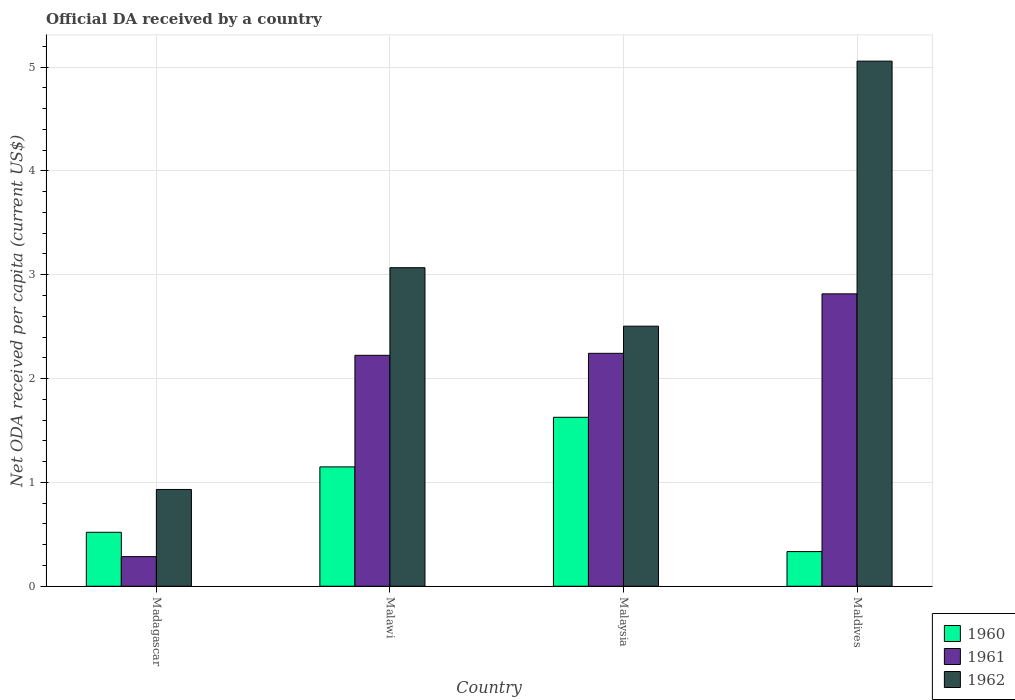How many different coloured bars are there?
Ensure brevity in your answer.  3. How many bars are there on the 2nd tick from the right?
Provide a succinct answer. 3. What is the label of the 2nd group of bars from the left?
Your answer should be very brief. Malawi. What is the ODA received in in 1960 in Madagascar?
Your response must be concise. 0.52. Across all countries, what is the maximum ODA received in in 1960?
Offer a very short reply. 1.63. Across all countries, what is the minimum ODA received in in 1960?
Offer a terse response. 0.33. In which country was the ODA received in in 1960 maximum?
Provide a short and direct response. Malaysia. In which country was the ODA received in in 1961 minimum?
Provide a succinct answer. Madagascar. What is the total ODA received in in 1962 in the graph?
Provide a short and direct response. 11.56. What is the difference between the ODA received in in 1960 in Malaysia and that in Maldives?
Offer a very short reply. 1.29. What is the difference between the ODA received in in 1962 in Malawi and the ODA received in in 1961 in Madagascar?
Give a very brief answer. 2.78. What is the average ODA received in in 1962 per country?
Keep it short and to the point. 2.89. What is the difference between the ODA received in of/in 1960 and ODA received in of/in 1961 in Malawi?
Your response must be concise. -1.07. In how many countries, is the ODA received in in 1962 greater than 2.4 US$?
Offer a very short reply. 3. What is the ratio of the ODA received in in 1961 in Malawi to that in Maldives?
Ensure brevity in your answer.  0.79. Is the ODA received in in 1960 in Madagascar less than that in Malawi?
Offer a very short reply. Yes. Is the difference between the ODA received in in 1960 in Malawi and Malaysia greater than the difference between the ODA received in in 1961 in Malawi and Malaysia?
Offer a very short reply. No. What is the difference between the highest and the second highest ODA received in in 1962?
Ensure brevity in your answer.  -0.56. What is the difference between the highest and the lowest ODA received in in 1960?
Your response must be concise. 1.29. In how many countries, is the ODA received in in 1961 greater than the average ODA received in in 1961 taken over all countries?
Give a very brief answer. 3. Is the sum of the ODA received in in 1960 in Madagascar and Malawi greater than the maximum ODA received in in 1961 across all countries?
Offer a very short reply. No. What does the 3rd bar from the right in Malaysia represents?
Offer a very short reply. 1960. How many countries are there in the graph?
Offer a terse response. 4. What is the difference between two consecutive major ticks on the Y-axis?
Ensure brevity in your answer.  1. Does the graph contain grids?
Ensure brevity in your answer.  Yes. How are the legend labels stacked?
Ensure brevity in your answer.  Vertical. What is the title of the graph?
Keep it short and to the point. Official DA received by a country. Does "1998" appear as one of the legend labels in the graph?
Offer a very short reply. No. What is the label or title of the X-axis?
Keep it short and to the point. Country. What is the label or title of the Y-axis?
Provide a succinct answer. Net ODA received per capita (current US$). What is the Net ODA received per capita (current US$) in 1960 in Madagascar?
Provide a short and direct response. 0.52. What is the Net ODA received per capita (current US$) in 1961 in Madagascar?
Offer a very short reply. 0.29. What is the Net ODA received per capita (current US$) of 1962 in Madagascar?
Offer a very short reply. 0.93. What is the Net ODA received per capita (current US$) of 1960 in Malawi?
Your answer should be very brief. 1.15. What is the Net ODA received per capita (current US$) of 1961 in Malawi?
Provide a succinct answer. 2.22. What is the Net ODA received per capita (current US$) of 1962 in Malawi?
Make the answer very short. 3.07. What is the Net ODA received per capita (current US$) in 1960 in Malaysia?
Your response must be concise. 1.63. What is the Net ODA received per capita (current US$) in 1961 in Malaysia?
Your answer should be very brief. 2.24. What is the Net ODA received per capita (current US$) in 1962 in Malaysia?
Give a very brief answer. 2.5. What is the Net ODA received per capita (current US$) of 1960 in Maldives?
Provide a succinct answer. 0.33. What is the Net ODA received per capita (current US$) of 1961 in Maldives?
Offer a terse response. 2.82. What is the Net ODA received per capita (current US$) in 1962 in Maldives?
Ensure brevity in your answer.  5.06. Across all countries, what is the maximum Net ODA received per capita (current US$) of 1960?
Offer a terse response. 1.63. Across all countries, what is the maximum Net ODA received per capita (current US$) of 1961?
Provide a succinct answer. 2.82. Across all countries, what is the maximum Net ODA received per capita (current US$) of 1962?
Give a very brief answer. 5.06. Across all countries, what is the minimum Net ODA received per capita (current US$) of 1960?
Your answer should be compact. 0.33. Across all countries, what is the minimum Net ODA received per capita (current US$) of 1961?
Give a very brief answer. 0.29. Across all countries, what is the minimum Net ODA received per capita (current US$) in 1962?
Offer a very short reply. 0.93. What is the total Net ODA received per capita (current US$) in 1960 in the graph?
Make the answer very short. 3.63. What is the total Net ODA received per capita (current US$) in 1961 in the graph?
Provide a succinct answer. 7.57. What is the total Net ODA received per capita (current US$) of 1962 in the graph?
Keep it short and to the point. 11.56. What is the difference between the Net ODA received per capita (current US$) in 1960 in Madagascar and that in Malawi?
Provide a succinct answer. -0.63. What is the difference between the Net ODA received per capita (current US$) of 1961 in Madagascar and that in Malawi?
Offer a terse response. -1.94. What is the difference between the Net ODA received per capita (current US$) of 1962 in Madagascar and that in Malawi?
Provide a succinct answer. -2.14. What is the difference between the Net ODA received per capita (current US$) of 1960 in Madagascar and that in Malaysia?
Offer a very short reply. -1.11. What is the difference between the Net ODA received per capita (current US$) of 1961 in Madagascar and that in Malaysia?
Make the answer very short. -1.96. What is the difference between the Net ODA received per capita (current US$) in 1962 in Madagascar and that in Malaysia?
Provide a succinct answer. -1.57. What is the difference between the Net ODA received per capita (current US$) of 1960 in Madagascar and that in Maldives?
Offer a terse response. 0.19. What is the difference between the Net ODA received per capita (current US$) in 1961 in Madagascar and that in Maldives?
Your response must be concise. -2.53. What is the difference between the Net ODA received per capita (current US$) in 1962 in Madagascar and that in Maldives?
Give a very brief answer. -4.13. What is the difference between the Net ODA received per capita (current US$) in 1960 in Malawi and that in Malaysia?
Provide a succinct answer. -0.48. What is the difference between the Net ODA received per capita (current US$) in 1961 in Malawi and that in Malaysia?
Provide a succinct answer. -0.02. What is the difference between the Net ODA received per capita (current US$) of 1962 in Malawi and that in Malaysia?
Your answer should be compact. 0.56. What is the difference between the Net ODA received per capita (current US$) of 1960 in Malawi and that in Maldives?
Ensure brevity in your answer.  0.82. What is the difference between the Net ODA received per capita (current US$) in 1961 in Malawi and that in Maldives?
Make the answer very short. -0.59. What is the difference between the Net ODA received per capita (current US$) of 1962 in Malawi and that in Maldives?
Your answer should be compact. -1.99. What is the difference between the Net ODA received per capita (current US$) of 1960 in Malaysia and that in Maldives?
Provide a succinct answer. 1.29. What is the difference between the Net ODA received per capita (current US$) of 1961 in Malaysia and that in Maldives?
Your answer should be very brief. -0.57. What is the difference between the Net ODA received per capita (current US$) of 1962 in Malaysia and that in Maldives?
Ensure brevity in your answer.  -2.55. What is the difference between the Net ODA received per capita (current US$) in 1960 in Madagascar and the Net ODA received per capita (current US$) in 1961 in Malawi?
Offer a very short reply. -1.7. What is the difference between the Net ODA received per capita (current US$) of 1960 in Madagascar and the Net ODA received per capita (current US$) of 1962 in Malawi?
Your answer should be very brief. -2.55. What is the difference between the Net ODA received per capita (current US$) in 1961 in Madagascar and the Net ODA received per capita (current US$) in 1962 in Malawi?
Your answer should be very brief. -2.78. What is the difference between the Net ODA received per capita (current US$) in 1960 in Madagascar and the Net ODA received per capita (current US$) in 1961 in Malaysia?
Offer a very short reply. -1.72. What is the difference between the Net ODA received per capita (current US$) of 1960 in Madagascar and the Net ODA received per capita (current US$) of 1962 in Malaysia?
Make the answer very short. -1.99. What is the difference between the Net ODA received per capita (current US$) of 1961 in Madagascar and the Net ODA received per capita (current US$) of 1962 in Malaysia?
Give a very brief answer. -2.22. What is the difference between the Net ODA received per capita (current US$) of 1960 in Madagascar and the Net ODA received per capita (current US$) of 1961 in Maldives?
Make the answer very short. -2.3. What is the difference between the Net ODA received per capita (current US$) in 1960 in Madagascar and the Net ODA received per capita (current US$) in 1962 in Maldives?
Your answer should be compact. -4.54. What is the difference between the Net ODA received per capita (current US$) in 1961 in Madagascar and the Net ODA received per capita (current US$) in 1962 in Maldives?
Ensure brevity in your answer.  -4.77. What is the difference between the Net ODA received per capita (current US$) of 1960 in Malawi and the Net ODA received per capita (current US$) of 1961 in Malaysia?
Make the answer very short. -1.09. What is the difference between the Net ODA received per capita (current US$) in 1960 in Malawi and the Net ODA received per capita (current US$) in 1962 in Malaysia?
Offer a very short reply. -1.36. What is the difference between the Net ODA received per capita (current US$) in 1961 in Malawi and the Net ODA received per capita (current US$) in 1962 in Malaysia?
Your answer should be compact. -0.28. What is the difference between the Net ODA received per capita (current US$) in 1960 in Malawi and the Net ODA received per capita (current US$) in 1961 in Maldives?
Your answer should be very brief. -1.67. What is the difference between the Net ODA received per capita (current US$) of 1960 in Malawi and the Net ODA received per capita (current US$) of 1962 in Maldives?
Provide a succinct answer. -3.91. What is the difference between the Net ODA received per capita (current US$) in 1961 in Malawi and the Net ODA received per capita (current US$) in 1962 in Maldives?
Offer a very short reply. -2.83. What is the difference between the Net ODA received per capita (current US$) of 1960 in Malaysia and the Net ODA received per capita (current US$) of 1961 in Maldives?
Provide a succinct answer. -1.19. What is the difference between the Net ODA received per capita (current US$) of 1960 in Malaysia and the Net ODA received per capita (current US$) of 1962 in Maldives?
Provide a succinct answer. -3.43. What is the difference between the Net ODA received per capita (current US$) in 1961 in Malaysia and the Net ODA received per capita (current US$) in 1962 in Maldives?
Give a very brief answer. -2.81. What is the average Net ODA received per capita (current US$) of 1960 per country?
Give a very brief answer. 0.91. What is the average Net ODA received per capita (current US$) of 1961 per country?
Your answer should be compact. 1.89. What is the average Net ODA received per capita (current US$) in 1962 per country?
Your answer should be very brief. 2.89. What is the difference between the Net ODA received per capita (current US$) in 1960 and Net ODA received per capita (current US$) in 1961 in Madagascar?
Keep it short and to the point. 0.23. What is the difference between the Net ODA received per capita (current US$) of 1960 and Net ODA received per capita (current US$) of 1962 in Madagascar?
Keep it short and to the point. -0.41. What is the difference between the Net ODA received per capita (current US$) of 1961 and Net ODA received per capita (current US$) of 1962 in Madagascar?
Offer a very short reply. -0.65. What is the difference between the Net ODA received per capita (current US$) of 1960 and Net ODA received per capita (current US$) of 1961 in Malawi?
Offer a very short reply. -1.07. What is the difference between the Net ODA received per capita (current US$) of 1960 and Net ODA received per capita (current US$) of 1962 in Malawi?
Keep it short and to the point. -1.92. What is the difference between the Net ODA received per capita (current US$) in 1961 and Net ODA received per capita (current US$) in 1962 in Malawi?
Offer a very short reply. -0.84. What is the difference between the Net ODA received per capita (current US$) in 1960 and Net ODA received per capita (current US$) in 1961 in Malaysia?
Give a very brief answer. -0.62. What is the difference between the Net ODA received per capita (current US$) in 1960 and Net ODA received per capita (current US$) in 1962 in Malaysia?
Keep it short and to the point. -0.88. What is the difference between the Net ODA received per capita (current US$) in 1961 and Net ODA received per capita (current US$) in 1962 in Malaysia?
Provide a short and direct response. -0.26. What is the difference between the Net ODA received per capita (current US$) of 1960 and Net ODA received per capita (current US$) of 1961 in Maldives?
Your answer should be very brief. -2.48. What is the difference between the Net ODA received per capita (current US$) of 1960 and Net ODA received per capita (current US$) of 1962 in Maldives?
Give a very brief answer. -4.72. What is the difference between the Net ODA received per capita (current US$) in 1961 and Net ODA received per capita (current US$) in 1962 in Maldives?
Offer a terse response. -2.24. What is the ratio of the Net ODA received per capita (current US$) in 1960 in Madagascar to that in Malawi?
Your answer should be very brief. 0.45. What is the ratio of the Net ODA received per capita (current US$) in 1961 in Madagascar to that in Malawi?
Make the answer very short. 0.13. What is the ratio of the Net ODA received per capita (current US$) of 1962 in Madagascar to that in Malawi?
Make the answer very short. 0.3. What is the ratio of the Net ODA received per capita (current US$) in 1960 in Madagascar to that in Malaysia?
Keep it short and to the point. 0.32. What is the ratio of the Net ODA received per capita (current US$) of 1961 in Madagascar to that in Malaysia?
Ensure brevity in your answer.  0.13. What is the ratio of the Net ODA received per capita (current US$) of 1962 in Madagascar to that in Malaysia?
Offer a terse response. 0.37. What is the ratio of the Net ODA received per capita (current US$) of 1960 in Madagascar to that in Maldives?
Ensure brevity in your answer.  1.56. What is the ratio of the Net ODA received per capita (current US$) of 1961 in Madagascar to that in Maldives?
Ensure brevity in your answer.  0.1. What is the ratio of the Net ODA received per capita (current US$) of 1962 in Madagascar to that in Maldives?
Ensure brevity in your answer.  0.18. What is the ratio of the Net ODA received per capita (current US$) in 1960 in Malawi to that in Malaysia?
Offer a terse response. 0.71. What is the ratio of the Net ODA received per capita (current US$) in 1961 in Malawi to that in Malaysia?
Your response must be concise. 0.99. What is the ratio of the Net ODA received per capita (current US$) of 1962 in Malawi to that in Malaysia?
Your answer should be compact. 1.22. What is the ratio of the Net ODA received per capita (current US$) of 1960 in Malawi to that in Maldives?
Your answer should be very brief. 3.44. What is the ratio of the Net ODA received per capita (current US$) in 1961 in Malawi to that in Maldives?
Keep it short and to the point. 0.79. What is the ratio of the Net ODA received per capita (current US$) in 1962 in Malawi to that in Maldives?
Your answer should be compact. 0.61. What is the ratio of the Net ODA received per capita (current US$) in 1960 in Malaysia to that in Maldives?
Your answer should be very brief. 4.88. What is the ratio of the Net ODA received per capita (current US$) of 1961 in Malaysia to that in Maldives?
Provide a succinct answer. 0.8. What is the ratio of the Net ODA received per capita (current US$) of 1962 in Malaysia to that in Maldives?
Offer a terse response. 0.5. What is the difference between the highest and the second highest Net ODA received per capita (current US$) in 1960?
Keep it short and to the point. 0.48. What is the difference between the highest and the second highest Net ODA received per capita (current US$) in 1961?
Offer a very short reply. 0.57. What is the difference between the highest and the second highest Net ODA received per capita (current US$) of 1962?
Give a very brief answer. 1.99. What is the difference between the highest and the lowest Net ODA received per capita (current US$) of 1960?
Provide a short and direct response. 1.29. What is the difference between the highest and the lowest Net ODA received per capita (current US$) of 1961?
Your answer should be very brief. 2.53. What is the difference between the highest and the lowest Net ODA received per capita (current US$) of 1962?
Keep it short and to the point. 4.13. 